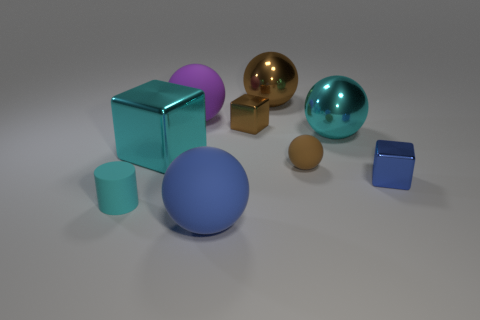What materials do the objects in the image seem to be made of? The objects in the image appear to be rendered with materials mimicking those found in reality. The spheres and the cube on the left seem reflective and could represent materials like glass or polished metal. The small cylinder and the cube on the right, with matte surfaces, could be interpreted as plastic or painted wood. 